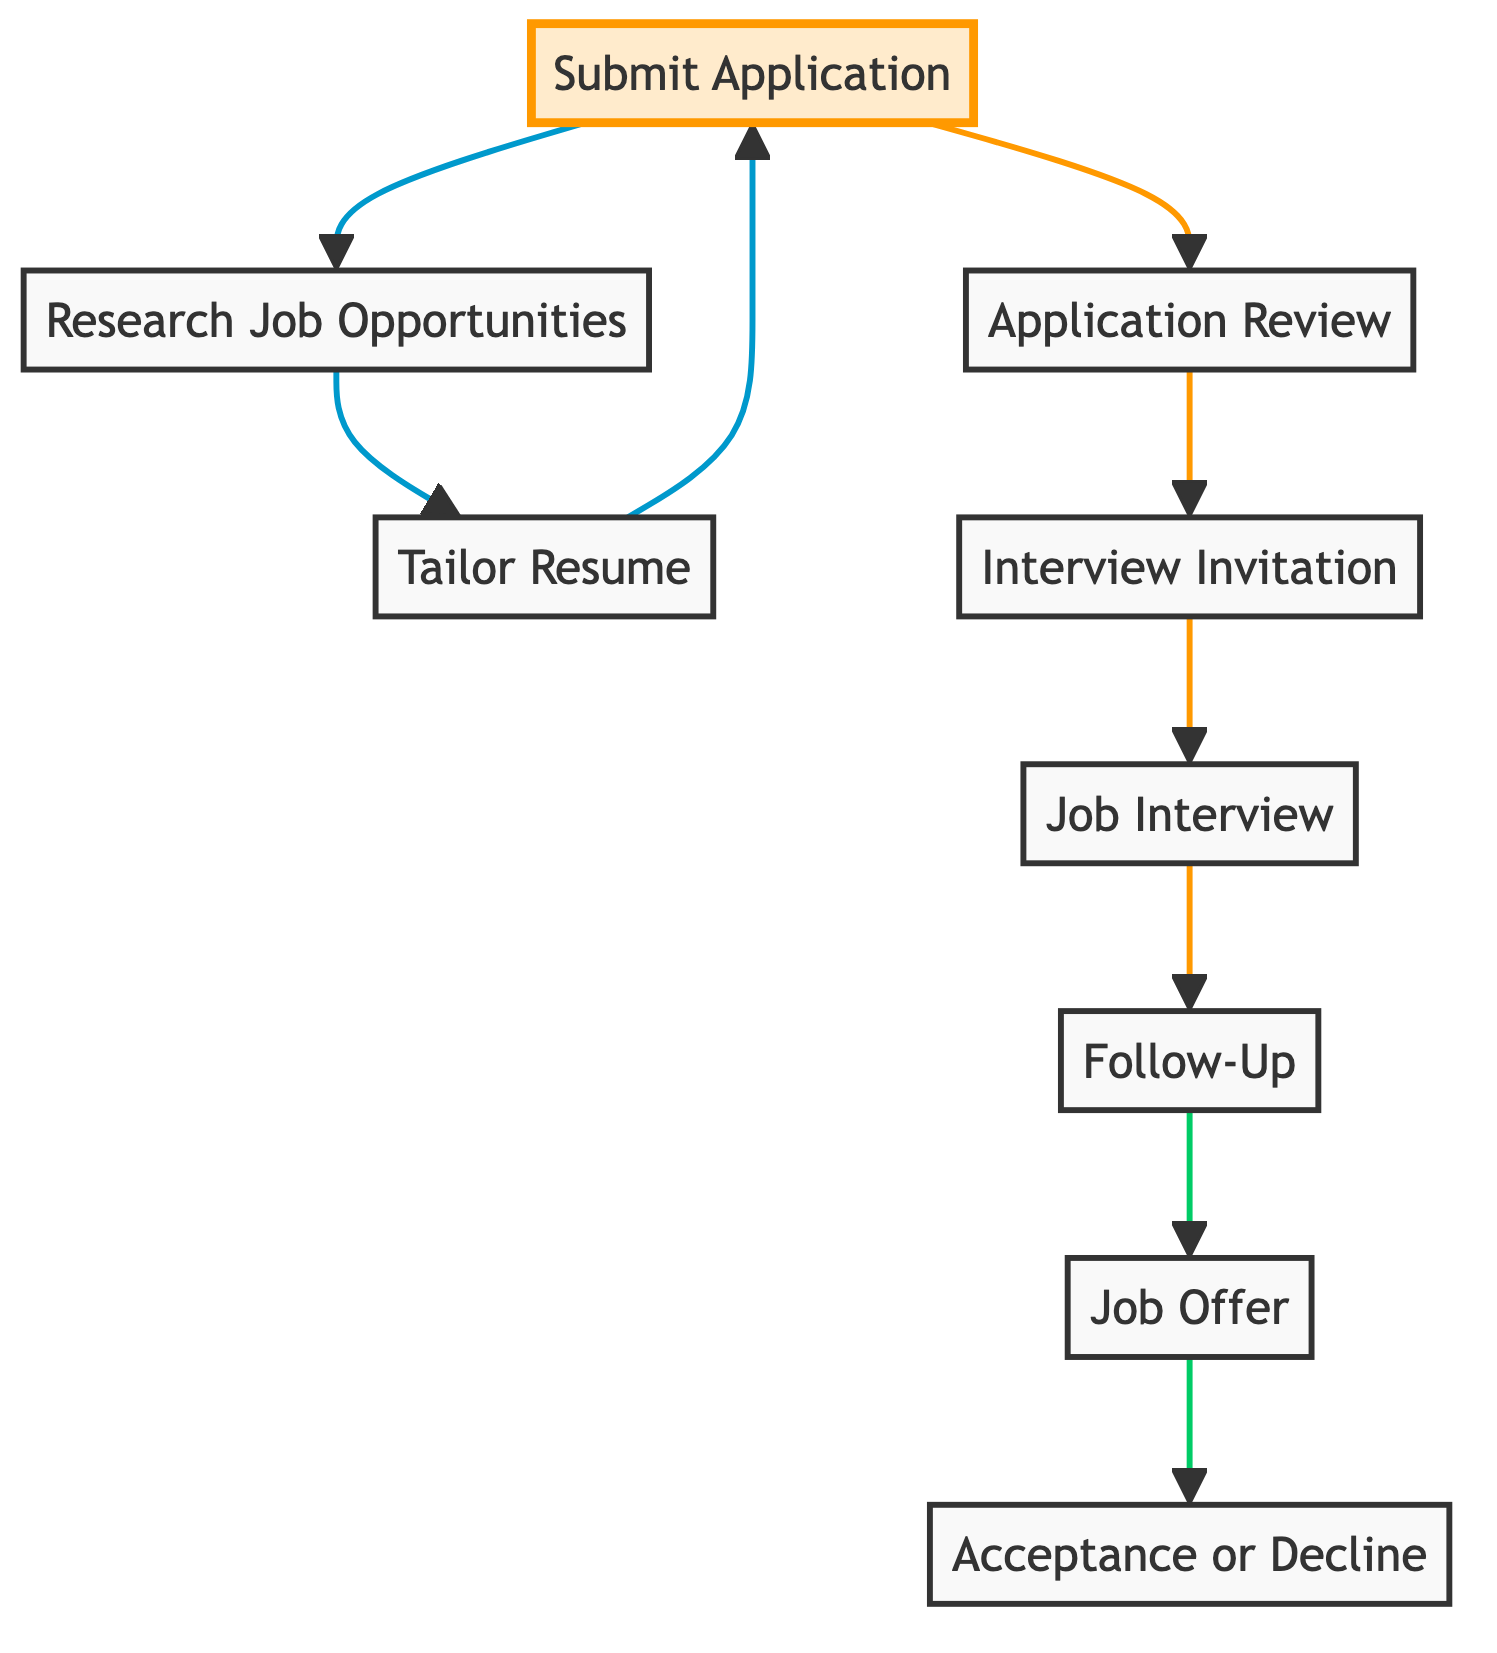What is the first step in the job application process? The first step in the diagram is "Self-Assessment," which is the initial stage where one evaluates skills, interests, and values.
Answer: Self-Assessment How many nodes are in the diagram? By counting each unique element provided in the data, there are ten distinct nodes representing different stages in the job application process.
Answer: Ten What follows after submitting an application? After submitting the application, the next node in the flow is "Application Review," where the hiring manager reviews applications to shortlist candidates.
Answer: Application Review Which step directly leads to receiving an interview invitation? The "Interview Invitation" node follows "Application Review," indicating that the invitation is received based on the shortlisted candidates.
Answer: Application Review What is the last step of the job application process? The last step in the flow is "Acceptance or Decline," representing the decision one makes after receiving a job offer.
Answer: Acceptance or Decline Which two steps are considered part of post-interview actions? The steps following the job interview are "Follow-Up" and "Job Offer," which involve sending a thank-you email and receiving the job offer, respectively.
Answer: Follow-Up and Job Offer How does the flowchart categorize the "Job Offer"? The "Job Offer" node is represented in green and denotes a positive outcome in the process, occurring after the "Follow-Up" stage.
Answer: Job Offer What is the relationship between "Job Interview" and "Follow-Up"? "Job Interview" flows directly into "Follow-Up," indicating that after the interview, sending a follow-up message is the expected next action.
Answer: Directly related Which step must be completed before tailoring the resume? Before tailoring the resume, the "Research Job Opportunities" step must be completed to identify suitable job positions.
Answer: Research Job Opportunities 